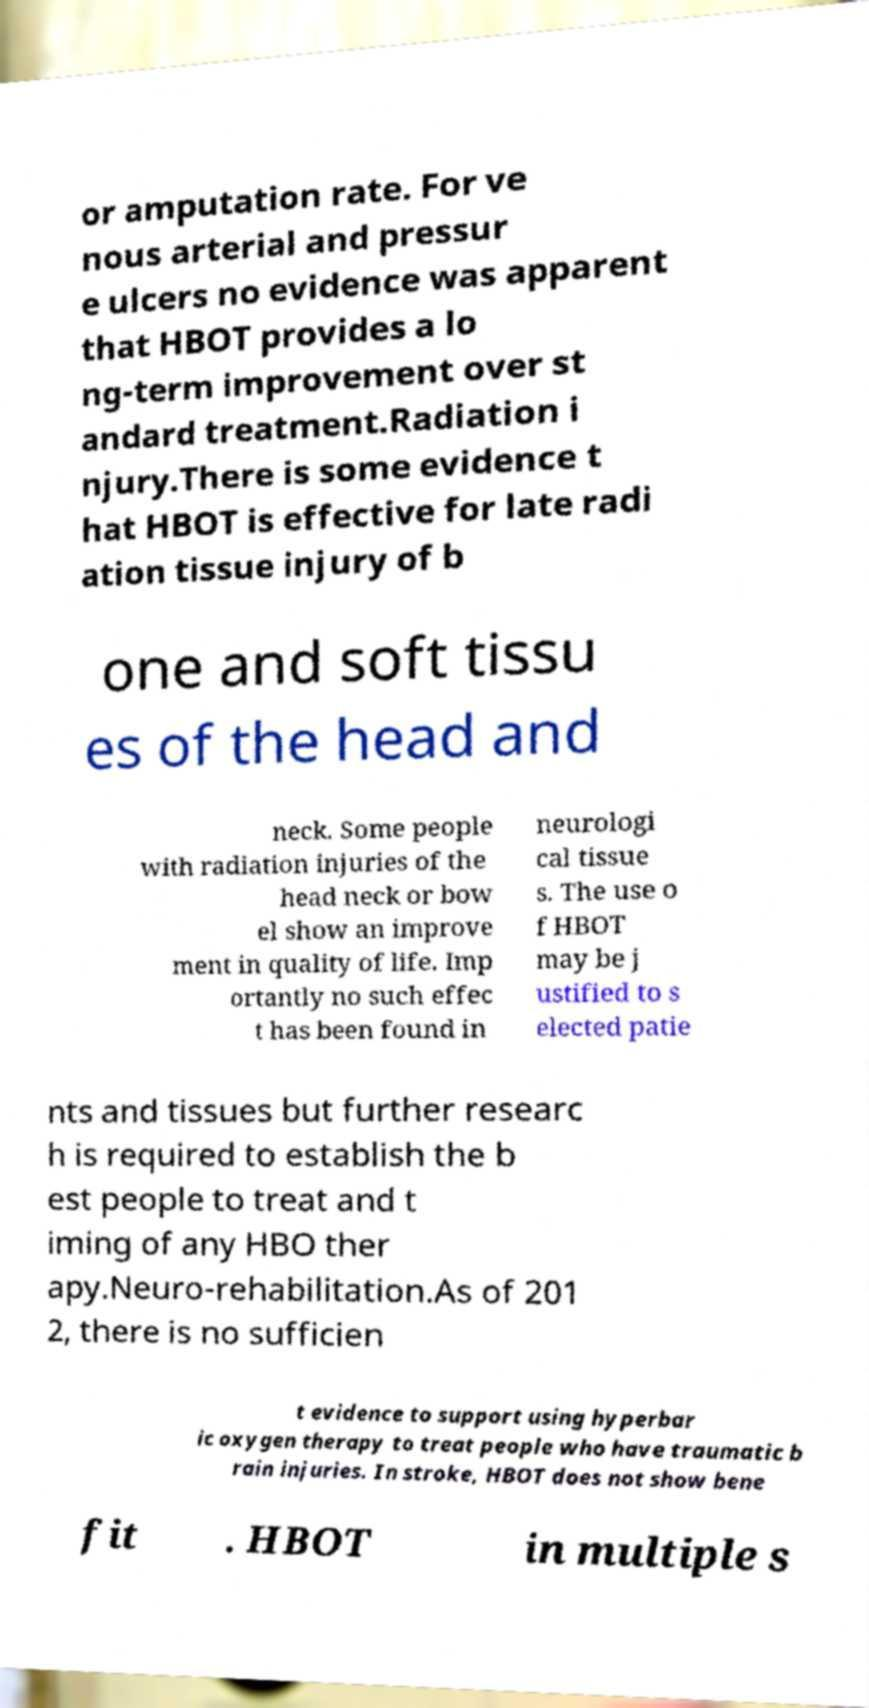Can you accurately transcribe the text from the provided image for me? or amputation rate. For ve nous arterial and pressur e ulcers no evidence was apparent that HBOT provides a lo ng-term improvement over st andard treatment.Radiation i njury.There is some evidence t hat HBOT is effective for late radi ation tissue injury of b one and soft tissu es of the head and neck. Some people with radiation injuries of the head neck or bow el show an improve ment in quality of life. Imp ortantly no such effec t has been found in neurologi cal tissue s. The use o f HBOT may be j ustified to s elected patie nts and tissues but further researc h is required to establish the b est people to treat and t iming of any HBO ther apy.Neuro-rehabilitation.As of 201 2, there is no sufficien t evidence to support using hyperbar ic oxygen therapy to treat people who have traumatic b rain injuries. In stroke, HBOT does not show bene fit . HBOT in multiple s 